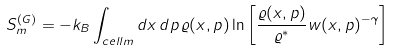<formula> <loc_0><loc_0><loc_500><loc_500>S _ { m } ^ { ( G ) } = - k _ { B } \int _ { c e l l m } d x \, d p \, \varrho ( x , p ) \ln \left [ \frac { \varrho ( x , p ) } { \varrho ^ { * } } w ( x , p ) ^ { - \gamma } \right ]</formula> 